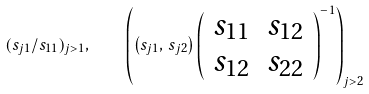<formula> <loc_0><loc_0><loc_500><loc_500>( s _ { j 1 } / s _ { 1 1 } ) _ { j > 1 } , \quad \left ( \left ( s _ { j 1 } , \, s _ { j 2 } \right ) \left ( \begin{array} { c c } s _ { 1 1 } & s _ { 1 2 } \\ s _ { 1 2 } & s _ { 2 2 } \end{array} \right ) ^ { - 1 } \right ) _ { j > 2 }</formula> 